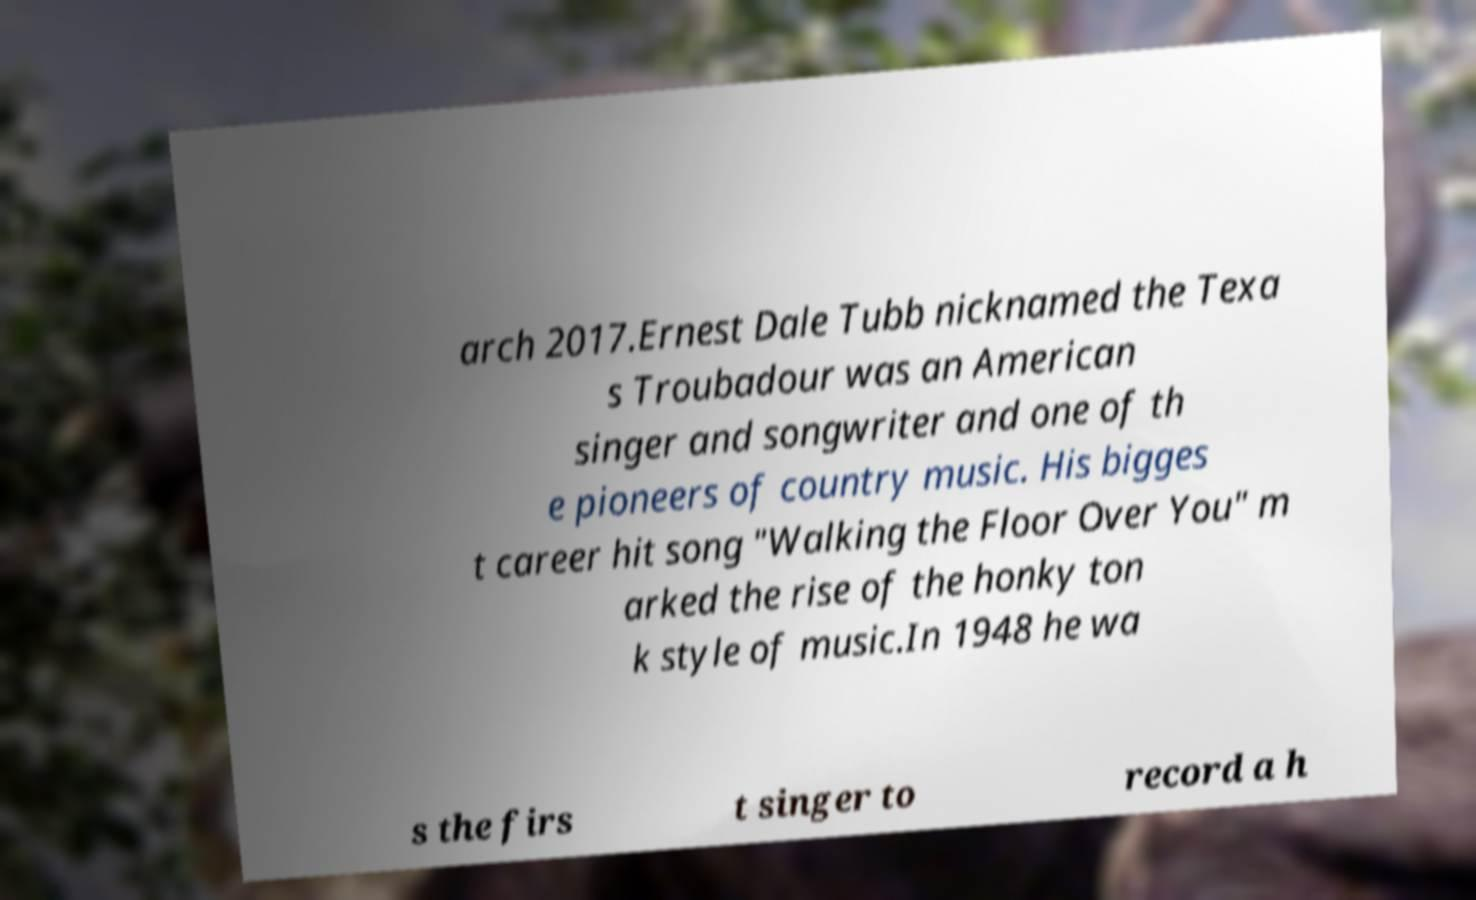For documentation purposes, I need the text within this image transcribed. Could you provide that? arch 2017.Ernest Dale Tubb nicknamed the Texa s Troubadour was an American singer and songwriter and one of th e pioneers of country music. His bigges t career hit song "Walking the Floor Over You" m arked the rise of the honky ton k style of music.In 1948 he wa s the firs t singer to record a h 